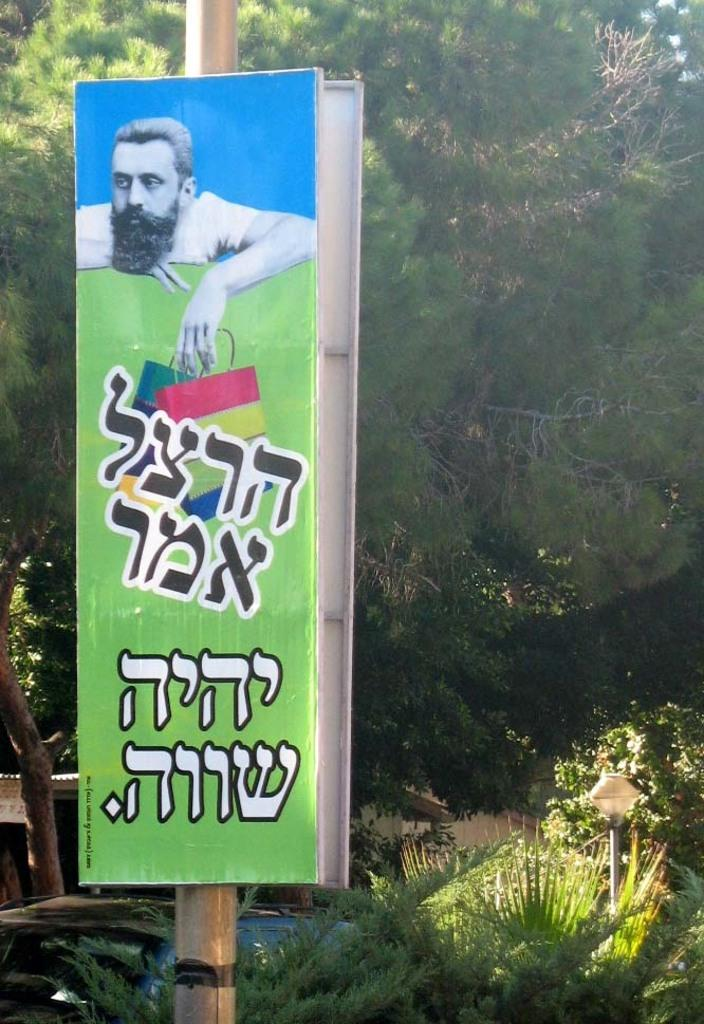What is the main object in the image? There is a pole in the image. What is attached to the pole? There is a board with an advertisement in the image. Can you describe the advertisement? The advertisement features a man's image. What can be seen in the background of the image? There are trees and plants on a path visible in the image. What language is the man speaking in the advertisement? The image does not provide any information about the language spoken by the man in the advertisement. Can you see a stream in the image? There is no stream visible in the image. 